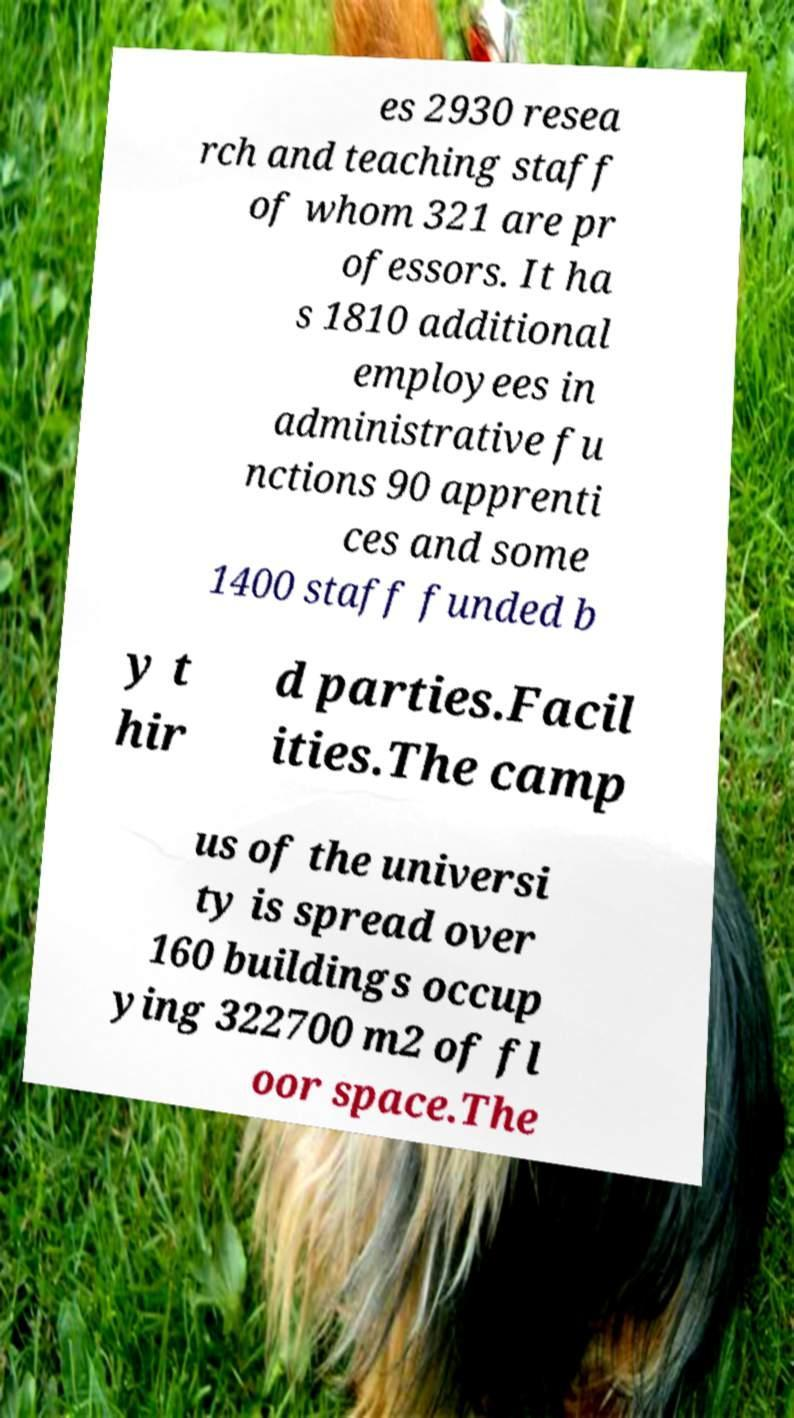Can you read and provide the text displayed in the image?This photo seems to have some interesting text. Can you extract and type it out for me? es 2930 resea rch and teaching staff of whom 321 are pr ofessors. It ha s 1810 additional employees in administrative fu nctions 90 apprenti ces and some 1400 staff funded b y t hir d parties.Facil ities.The camp us of the universi ty is spread over 160 buildings occup ying 322700 m2 of fl oor space.The 